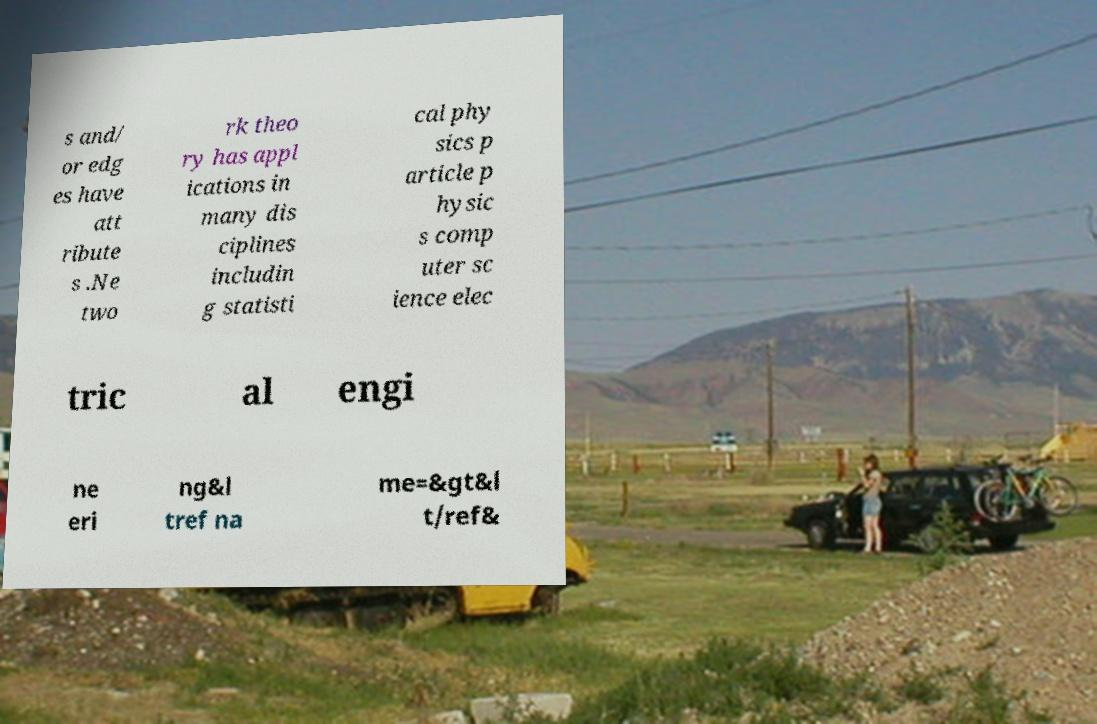Please read and relay the text visible in this image. What does it say? s and/ or edg es have att ribute s .Ne two rk theo ry has appl ications in many dis ciplines includin g statisti cal phy sics p article p hysic s comp uter sc ience elec tric al engi ne eri ng&l tref na me=&gt&l t/ref& 